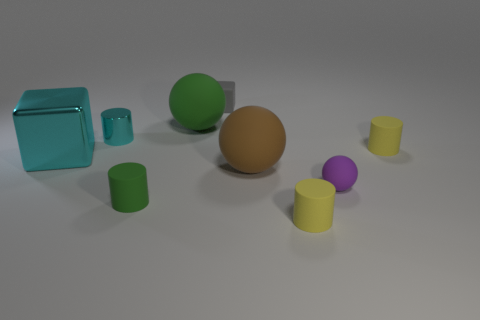Subtract all large green balls. How many balls are left? 2 Add 1 big blue cylinders. How many objects exist? 10 Subtract all purple cubes. How many yellow cylinders are left? 2 Subtract all green cylinders. How many cylinders are left? 3 Subtract all balls. How many objects are left? 6 Add 1 small purple things. How many small purple things exist? 2 Subtract 0 green cubes. How many objects are left? 9 Subtract all purple balls. Subtract all gray cylinders. How many balls are left? 2 Subtract all small green rubber objects. Subtract all small cyan cylinders. How many objects are left? 7 Add 1 cyan cubes. How many cyan cubes are left? 2 